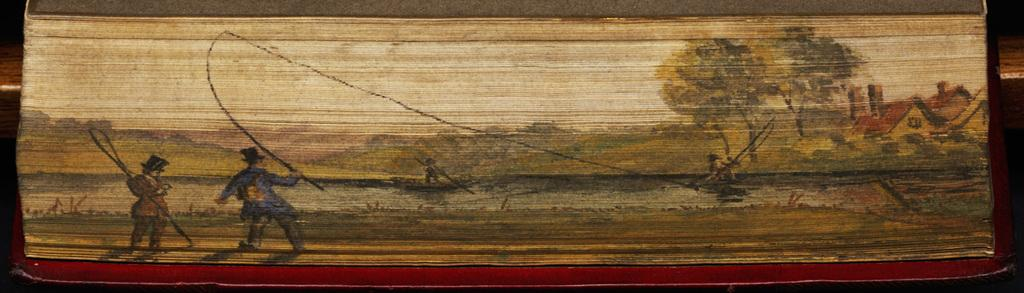What are the persons in the image holding? The persons in the image are holding fishing nets. How are the fishing nets being held? The persons are holding the fishing nets in their hands. What can be seen in the background of the image? There are houses and trees in the background of the image. What type of selection process is being used to choose the best fishing net in the image? There is no indication of a selection process in the image; the persons are simply holding fishing nets in their hands. 